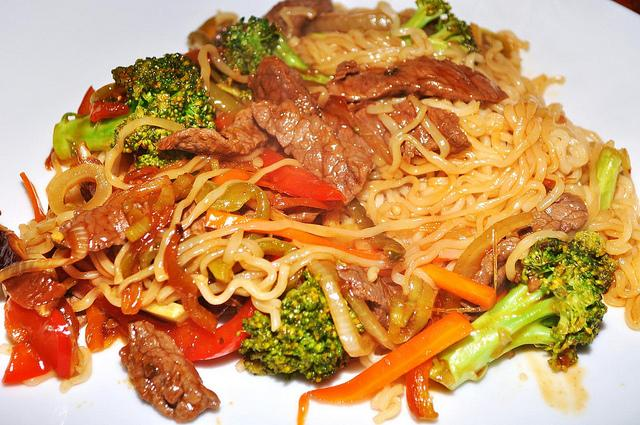What is touching the broccoli?

Choices:
A) cats paw
B) pasta noodles
C) clowns nose
D) babys hand pasta noodles 